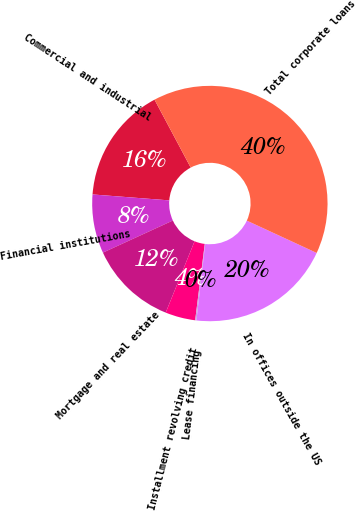Convert chart to OTSL. <chart><loc_0><loc_0><loc_500><loc_500><pie_chart><fcel>Commercial and industrial<fcel>Financial institutions<fcel>Mortgage and real estate<fcel>Installment revolving credit<fcel>Lease financing<fcel>In offices outside the US<fcel>Total corporate loans<nl><fcel>15.98%<fcel>8.08%<fcel>12.03%<fcel>4.13%<fcel>0.17%<fcel>19.93%<fcel>39.69%<nl></chart> 